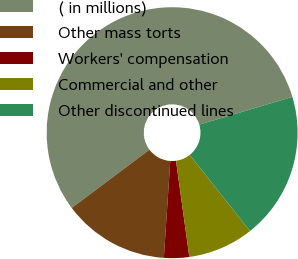Convert chart to OTSL. <chart><loc_0><loc_0><loc_500><loc_500><pie_chart><fcel>( in millions)<fcel>Other mass torts<fcel>Workers' compensation<fcel>Commercial and other<fcel>Other discontinued lines<nl><fcel>55.62%<fcel>13.71%<fcel>3.24%<fcel>8.47%<fcel>18.95%<nl></chart> 